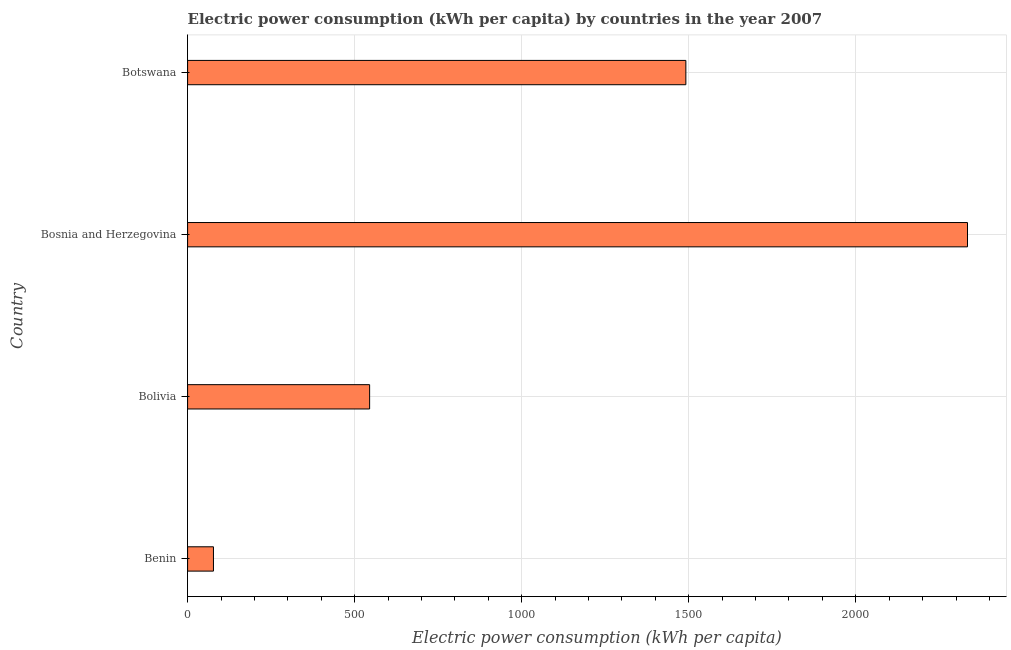Does the graph contain any zero values?
Your answer should be very brief. No. What is the title of the graph?
Offer a terse response. Electric power consumption (kWh per capita) by countries in the year 2007. What is the label or title of the X-axis?
Your response must be concise. Electric power consumption (kWh per capita). What is the electric power consumption in Benin?
Offer a terse response. 77.4. Across all countries, what is the maximum electric power consumption?
Your answer should be compact. 2334.38. Across all countries, what is the minimum electric power consumption?
Your answer should be very brief. 77.4. In which country was the electric power consumption maximum?
Your answer should be compact. Bosnia and Herzegovina. In which country was the electric power consumption minimum?
Give a very brief answer. Benin. What is the sum of the electric power consumption?
Your answer should be compact. 4447.99. What is the difference between the electric power consumption in Benin and Bosnia and Herzegovina?
Your response must be concise. -2256.98. What is the average electric power consumption per country?
Give a very brief answer. 1112. What is the median electric power consumption?
Provide a succinct answer. 1018.1. What is the ratio of the electric power consumption in Bosnia and Herzegovina to that in Botswana?
Keep it short and to the point. 1.56. What is the difference between the highest and the second highest electric power consumption?
Make the answer very short. 843. What is the difference between the highest and the lowest electric power consumption?
Offer a terse response. 2256.98. In how many countries, is the electric power consumption greater than the average electric power consumption taken over all countries?
Offer a very short reply. 2. How many bars are there?
Make the answer very short. 4. Are all the bars in the graph horizontal?
Give a very brief answer. Yes. What is the difference between two consecutive major ticks on the X-axis?
Ensure brevity in your answer.  500. Are the values on the major ticks of X-axis written in scientific E-notation?
Provide a succinct answer. No. What is the Electric power consumption (kWh per capita) in Benin?
Your answer should be very brief. 77.4. What is the Electric power consumption (kWh per capita) in Bolivia?
Provide a succinct answer. 544.83. What is the Electric power consumption (kWh per capita) in Bosnia and Herzegovina?
Your answer should be compact. 2334.38. What is the Electric power consumption (kWh per capita) of Botswana?
Give a very brief answer. 1491.38. What is the difference between the Electric power consumption (kWh per capita) in Benin and Bolivia?
Offer a very short reply. -467.43. What is the difference between the Electric power consumption (kWh per capita) in Benin and Bosnia and Herzegovina?
Provide a succinct answer. -2256.98. What is the difference between the Electric power consumption (kWh per capita) in Benin and Botswana?
Your response must be concise. -1413.97. What is the difference between the Electric power consumption (kWh per capita) in Bolivia and Bosnia and Herzegovina?
Offer a very short reply. -1789.55. What is the difference between the Electric power consumption (kWh per capita) in Bolivia and Botswana?
Keep it short and to the point. -946.55. What is the difference between the Electric power consumption (kWh per capita) in Bosnia and Herzegovina and Botswana?
Keep it short and to the point. 843. What is the ratio of the Electric power consumption (kWh per capita) in Benin to that in Bolivia?
Provide a succinct answer. 0.14. What is the ratio of the Electric power consumption (kWh per capita) in Benin to that in Bosnia and Herzegovina?
Offer a terse response. 0.03. What is the ratio of the Electric power consumption (kWh per capita) in Benin to that in Botswana?
Keep it short and to the point. 0.05. What is the ratio of the Electric power consumption (kWh per capita) in Bolivia to that in Bosnia and Herzegovina?
Ensure brevity in your answer.  0.23. What is the ratio of the Electric power consumption (kWh per capita) in Bolivia to that in Botswana?
Keep it short and to the point. 0.36. What is the ratio of the Electric power consumption (kWh per capita) in Bosnia and Herzegovina to that in Botswana?
Provide a short and direct response. 1.56. 